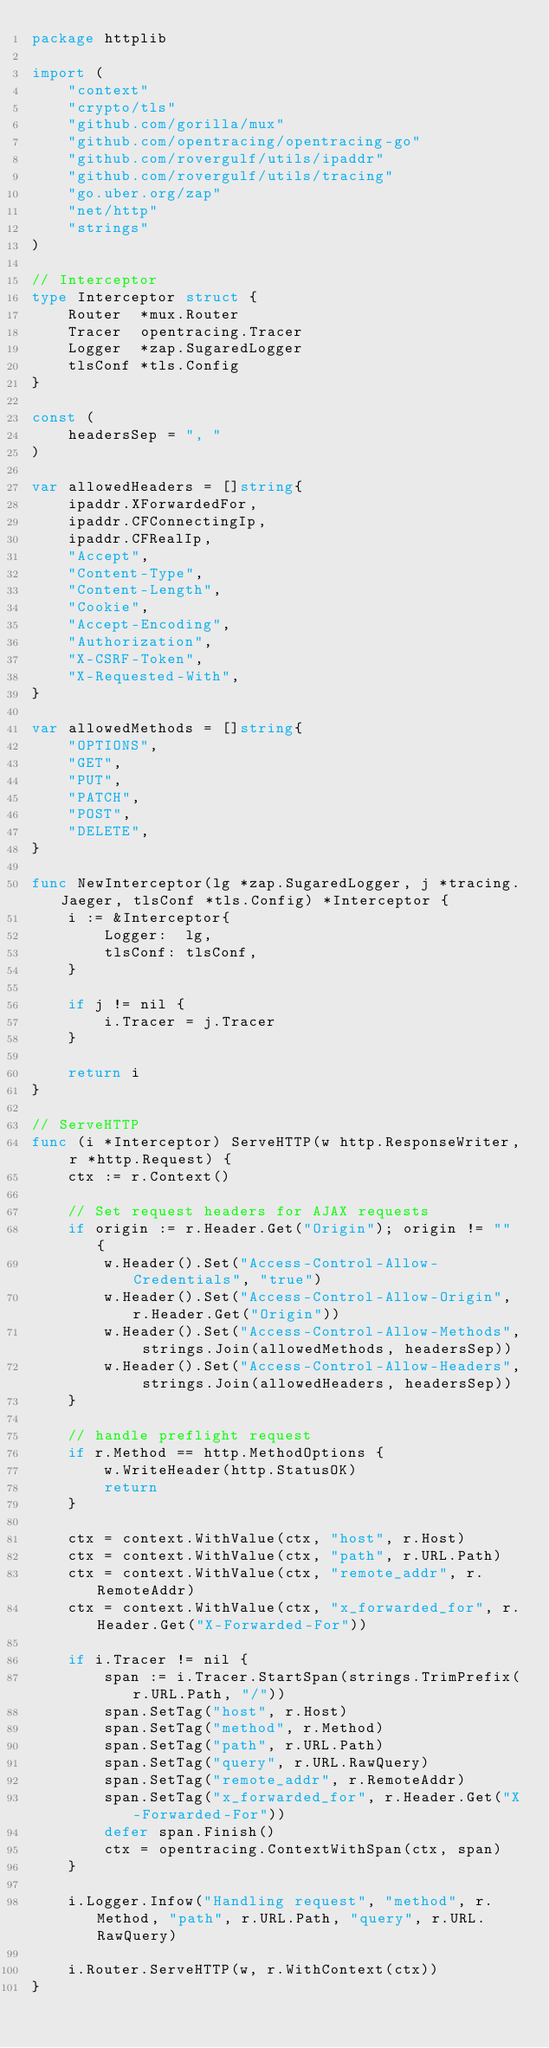<code> <loc_0><loc_0><loc_500><loc_500><_Go_>package httplib

import (
	"context"
	"crypto/tls"
	"github.com/gorilla/mux"
	"github.com/opentracing/opentracing-go"
	"github.com/rovergulf/utils/ipaddr"
	"github.com/rovergulf/utils/tracing"
	"go.uber.org/zap"
	"net/http"
	"strings"
)

// Interceptor
type Interceptor struct {
	Router  *mux.Router
	Tracer  opentracing.Tracer
	Logger  *zap.SugaredLogger
	tlsConf *tls.Config
}

const (
	headersSep = ", "
)

var allowedHeaders = []string{
	ipaddr.XForwardedFor,
	ipaddr.CFConnectingIp,
	ipaddr.CFRealIp,
	"Accept",
	"Content-Type",
	"Content-Length",
	"Cookie",
	"Accept-Encoding",
	"Authorization",
	"X-CSRF-Token",
	"X-Requested-With",
}

var allowedMethods = []string{
	"OPTIONS",
	"GET",
	"PUT",
	"PATCH",
	"POST",
	"DELETE",
}

func NewInterceptor(lg *zap.SugaredLogger, j *tracing.Jaeger, tlsConf *tls.Config) *Interceptor {
	i := &Interceptor{
		Logger:  lg,
		tlsConf: tlsConf,
	}

	if j != nil {
		i.Tracer = j.Tracer
	}

	return i
}

// ServeHTTP
func (i *Interceptor) ServeHTTP(w http.ResponseWriter, r *http.Request) {
	ctx := r.Context()

	// Set request headers for AJAX requests
	if origin := r.Header.Get("Origin"); origin != "" {
		w.Header().Set("Access-Control-Allow-Credentials", "true")
		w.Header().Set("Access-Control-Allow-Origin", r.Header.Get("Origin"))
		w.Header().Set("Access-Control-Allow-Methods", strings.Join(allowedMethods, headersSep))
		w.Header().Set("Access-Control-Allow-Headers", strings.Join(allowedHeaders, headersSep))
	}

	// handle preflight request
	if r.Method == http.MethodOptions {
		w.WriteHeader(http.StatusOK)
		return
	}

	ctx = context.WithValue(ctx, "host", r.Host)
	ctx = context.WithValue(ctx, "path", r.URL.Path)
	ctx = context.WithValue(ctx, "remote_addr", r.RemoteAddr)
	ctx = context.WithValue(ctx, "x_forwarded_for", r.Header.Get("X-Forwarded-For"))

	if i.Tracer != nil {
		span := i.Tracer.StartSpan(strings.TrimPrefix(r.URL.Path, "/"))
		span.SetTag("host", r.Host)
		span.SetTag("method", r.Method)
		span.SetTag("path", r.URL.Path)
		span.SetTag("query", r.URL.RawQuery)
		span.SetTag("remote_addr", r.RemoteAddr)
		span.SetTag("x_forwarded_for", r.Header.Get("X-Forwarded-For"))
		defer span.Finish()
		ctx = opentracing.ContextWithSpan(ctx, span)
	}

	i.Logger.Infow("Handling request", "method", r.Method, "path", r.URL.Path, "query", r.URL.RawQuery)

	i.Router.ServeHTTP(w, r.WithContext(ctx))
}
</code> 